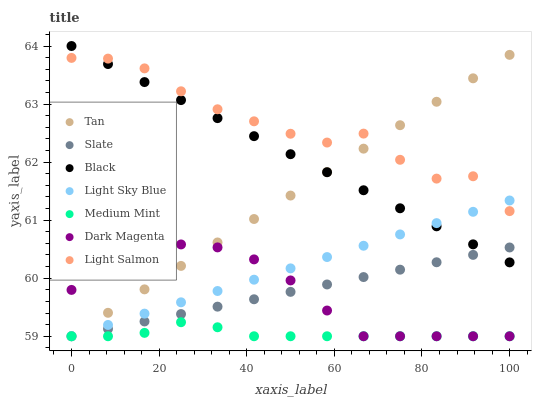Does Medium Mint have the minimum area under the curve?
Answer yes or no. Yes. Does Light Salmon have the maximum area under the curve?
Answer yes or no. Yes. Does Dark Magenta have the minimum area under the curve?
Answer yes or no. No. Does Dark Magenta have the maximum area under the curve?
Answer yes or no. No. Is Slate the smoothest?
Answer yes or no. Yes. Is Light Salmon the roughest?
Answer yes or no. Yes. Is Dark Magenta the smoothest?
Answer yes or no. No. Is Dark Magenta the roughest?
Answer yes or no. No. Does Medium Mint have the lowest value?
Answer yes or no. Yes. Does Light Salmon have the lowest value?
Answer yes or no. No. Does Black have the highest value?
Answer yes or no. Yes. Does Light Salmon have the highest value?
Answer yes or no. No. Is Dark Magenta less than Black?
Answer yes or no. Yes. Is Light Salmon greater than Slate?
Answer yes or no. Yes. Does Light Sky Blue intersect Tan?
Answer yes or no. Yes. Is Light Sky Blue less than Tan?
Answer yes or no. No. Is Light Sky Blue greater than Tan?
Answer yes or no. No. Does Dark Magenta intersect Black?
Answer yes or no. No. 